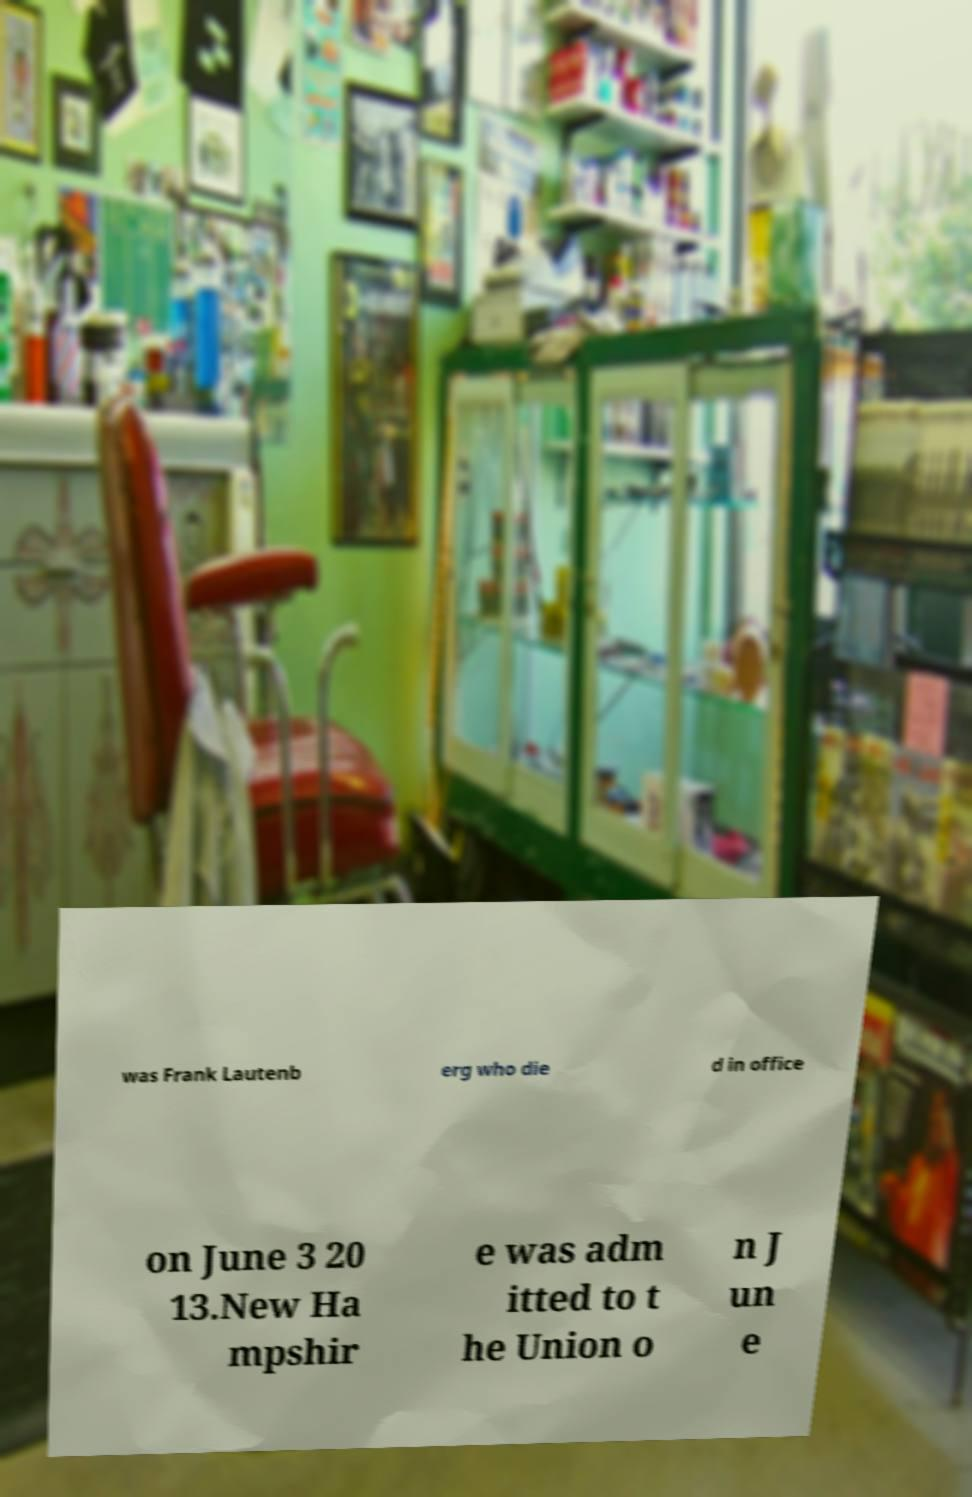Could you extract and type out the text from this image? was Frank Lautenb erg who die d in office on June 3 20 13.New Ha mpshir e was adm itted to t he Union o n J un e 